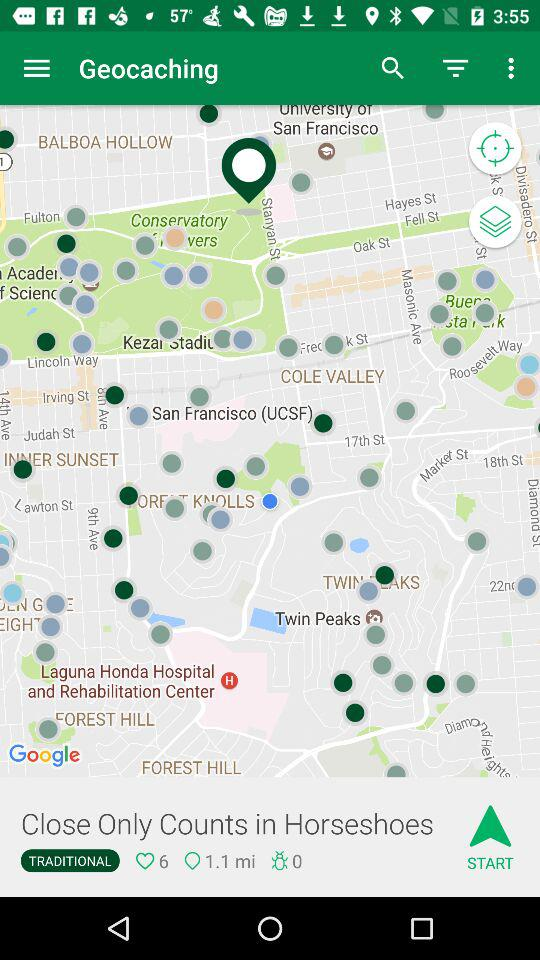How many people like "Close Only Counts in Horseshoes" in "Geocaching"? There are 6 people who like "Close Only Counts in Horseshoes" in "Geocaching". 